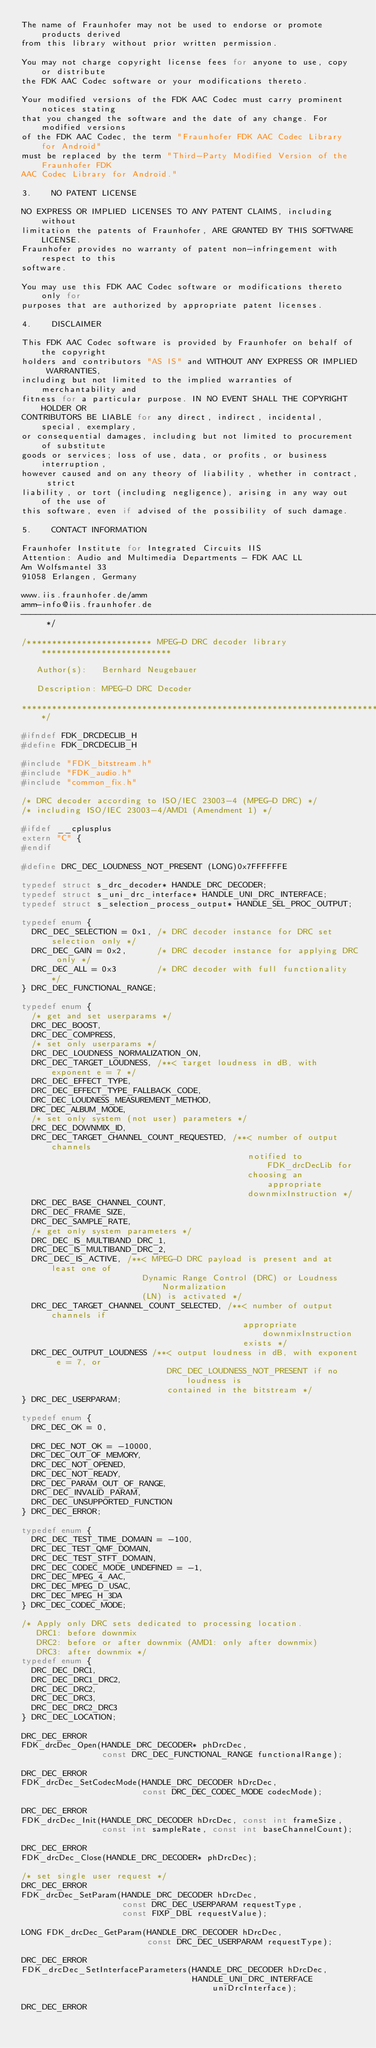Convert code to text. <code><loc_0><loc_0><loc_500><loc_500><_C_>The name of Fraunhofer may not be used to endorse or promote products derived
from this library without prior written permission.

You may not charge copyright license fees for anyone to use, copy or distribute
the FDK AAC Codec software or your modifications thereto.

Your modified versions of the FDK AAC Codec must carry prominent notices stating
that you changed the software and the date of any change. For modified versions
of the FDK AAC Codec, the term "Fraunhofer FDK AAC Codec Library for Android"
must be replaced by the term "Third-Party Modified Version of the Fraunhofer FDK
AAC Codec Library for Android."

3.    NO PATENT LICENSE

NO EXPRESS OR IMPLIED LICENSES TO ANY PATENT CLAIMS, including without
limitation the patents of Fraunhofer, ARE GRANTED BY THIS SOFTWARE LICENSE.
Fraunhofer provides no warranty of patent non-infringement with respect to this
software.

You may use this FDK AAC Codec software or modifications thereto only for
purposes that are authorized by appropriate patent licenses.

4.    DISCLAIMER

This FDK AAC Codec software is provided by Fraunhofer on behalf of the copyright
holders and contributors "AS IS" and WITHOUT ANY EXPRESS OR IMPLIED WARRANTIES,
including but not limited to the implied warranties of merchantability and
fitness for a particular purpose. IN NO EVENT SHALL THE COPYRIGHT HOLDER OR
CONTRIBUTORS BE LIABLE for any direct, indirect, incidental, special, exemplary,
or consequential damages, including but not limited to procurement of substitute
goods or services; loss of use, data, or profits, or business interruption,
however caused and on any theory of liability, whether in contract, strict
liability, or tort (including negligence), arising in any way out of the use of
this software, even if advised of the possibility of such damage.

5.    CONTACT INFORMATION

Fraunhofer Institute for Integrated Circuits IIS
Attention: Audio and Multimedia Departments - FDK AAC LL
Am Wolfsmantel 33
91058 Erlangen, Germany

www.iis.fraunhofer.de/amm
amm-info@iis.fraunhofer.de
----------------------------------------------------------------------------- */

/************************* MPEG-D DRC decoder library **************************

   Author(s):   Bernhard Neugebauer

   Description: MPEG-D DRC Decoder

*******************************************************************************/

#ifndef FDK_DRCDECLIB_H
#define FDK_DRCDECLIB_H

#include "FDK_bitstream.h"
#include "FDK_audio.h"
#include "common_fix.h"

/* DRC decoder according to ISO/IEC 23003-4 (MPEG-D DRC) */
/* including ISO/IEC 23003-4/AMD1 (Amendment 1) */

#ifdef __cplusplus
extern "C" {
#endif

#define DRC_DEC_LOUDNESS_NOT_PRESENT (LONG)0x7FFFFFFE

typedef struct s_drc_decoder* HANDLE_DRC_DECODER;
typedef struct s_uni_drc_interface* HANDLE_UNI_DRC_INTERFACE;
typedef struct s_selection_process_output* HANDLE_SEL_PROC_OUTPUT;

typedef enum {
  DRC_DEC_SELECTION = 0x1, /* DRC decoder instance for DRC set selection only */
  DRC_DEC_GAIN = 0x2,      /* DRC decoder instance for applying DRC only */
  DRC_DEC_ALL = 0x3        /* DRC decoder with full functionality */
} DRC_DEC_FUNCTIONAL_RANGE;

typedef enum {
  /* get and set userparams */
  DRC_DEC_BOOST,
  DRC_DEC_COMPRESS,
  /* set only userparams */
  DRC_DEC_LOUDNESS_NORMALIZATION_ON,
  DRC_DEC_TARGET_LOUDNESS, /**< target loudness in dB, with exponent e = 7 */
  DRC_DEC_EFFECT_TYPE,
  DRC_DEC_EFFECT_TYPE_FALLBACK_CODE,
  DRC_DEC_LOUDNESS_MEASUREMENT_METHOD,
  DRC_DEC_ALBUM_MODE,
  /* set only system (not user) parameters */
  DRC_DEC_DOWNMIX_ID,
  DRC_DEC_TARGET_CHANNEL_COUNT_REQUESTED, /**< number of output channels
                                             notified to FDK_drcDecLib for
                                             choosing an appropriate
                                             downmixInstruction */
  DRC_DEC_BASE_CHANNEL_COUNT,
  DRC_DEC_FRAME_SIZE,
  DRC_DEC_SAMPLE_RATE,
  /* get only system parameters */
  DRC_DEC_IS_MULTIBAND_DRC_1,
  DRC_DEC_IS_MULTIBAND_DRC_2,
  DRC_DEC_IS_ACTIVE, /**< MPEG-D DRC payload is present and at least one of
                        Dynamic Range Control (DRC) or Loudness Normalization
                        (LN) is activated */
  DRC_DEC_TARGET_CHANNEL_COUNT_SELECTED, /**< number of output channels if
                                            appropriate downmixInstruction
                                            exists */
  DRC_DEC_OUTPUT_LOUDNESS /**< output loudness in dB, with exponent e = 7, or
                             DRC_DEC_LOUDNESS_NOT_PRESENT if no loudness is
                             contained in the bitstream */
} DRC_DEC_USERPARAM;

typedef enum {
  DRC_DEC_OK = 0,

  DRC_DEC_NOT_OK = -10000,
  DRC_DEC_OUT_OF_MEMORY,
  DRC_DEC_NOT_OPENED,
  DRC_DEC_NOT_READY,
  DRC_DEC_PARAM_OUT_OF_RANGE,
  DRC_DEC_INVALID_PARAM,
  DRC_DEC_UNSUPPORTED_FUNCTION
} DRC_DEC_ERROR;

typedef enum {
  DRC_DEC_TEST_TIME_DOMAIN = -100,
  DRC_DEC_TEST_QMF_DOMAIN,
  DRC_DEC_TEST_STFT_DOMAIN,
  DRC_DEC_CODEC_MODE_UNDEFINED = -1,
  DRC_DEC_MPEG_4_AAC,
  DRC_DEC_MPEG_D_USAC,
  DRC_DEC_MPEG_H_3DA
} DRC_DEC_CODEC_MODE;

/* Apply only DRC sets dedicated to processing location.
   DRC1: before downmix
   DRC2: before or after downmix (AMD1: only after downmix)
   DRC3: after downmix */
typedef enum {
  DRC_DEC_DRC1,
  DRC_DEC_DRC1_DRC2,
  DRC_DEC_DRC2,
  DRC_DEC_DRC3,
  DRC_DEC_DRC2_DRC3
} DRC_DEC_LOCATION;

DRC_DEC_ERROR
FDK_drcDec_Open(HANDLE_DRC_DECODER* phDrcDec,
                const DRC_DEC_FUNCTIONAL_RANGE functionalRange);

DRC_DEC_ERROR
FDK_drcDec_SetCodecMode(HANDLE_DRC_DECODER hDrcDec,
                        const DRC_DEC_CODEC_MODE codecMode);

DRC_DEC_ERROR
FDK_drcDec_Init(HANDLE_DRC_DECODER hDrcDec, const int frameSize,
                const int sampleRate, const int baseChannelCount);

DRC_DEC_ERROR
FDK_drcDec_Close(HANDLE_DRC_DECODER* phDrcDec);

/* set single user request */
DRC_DEC_ERROR
FDK_drcDec_SetParam(HANDLE_DRC_DECODER hDrcDec,
                    const DRC_DEC_USERPARAM requestType,
                    const FIXP_DBL requestValue);

LONG FDK_drcDec_GetParam(HANDLE_DRC_DECODER hDrcDec,
                         const DRC_DEC_USERPARAM requestType);

DRC_DEC_ERROR
FDK_drcDec_SetInterfaceParameters(HANDLE_DRC_DECODER hDrcDec,
                                  HANDLE_UNI_DRC_INTERFACE uniDrcInterface);

DRC_DEC_ERROR</code> 